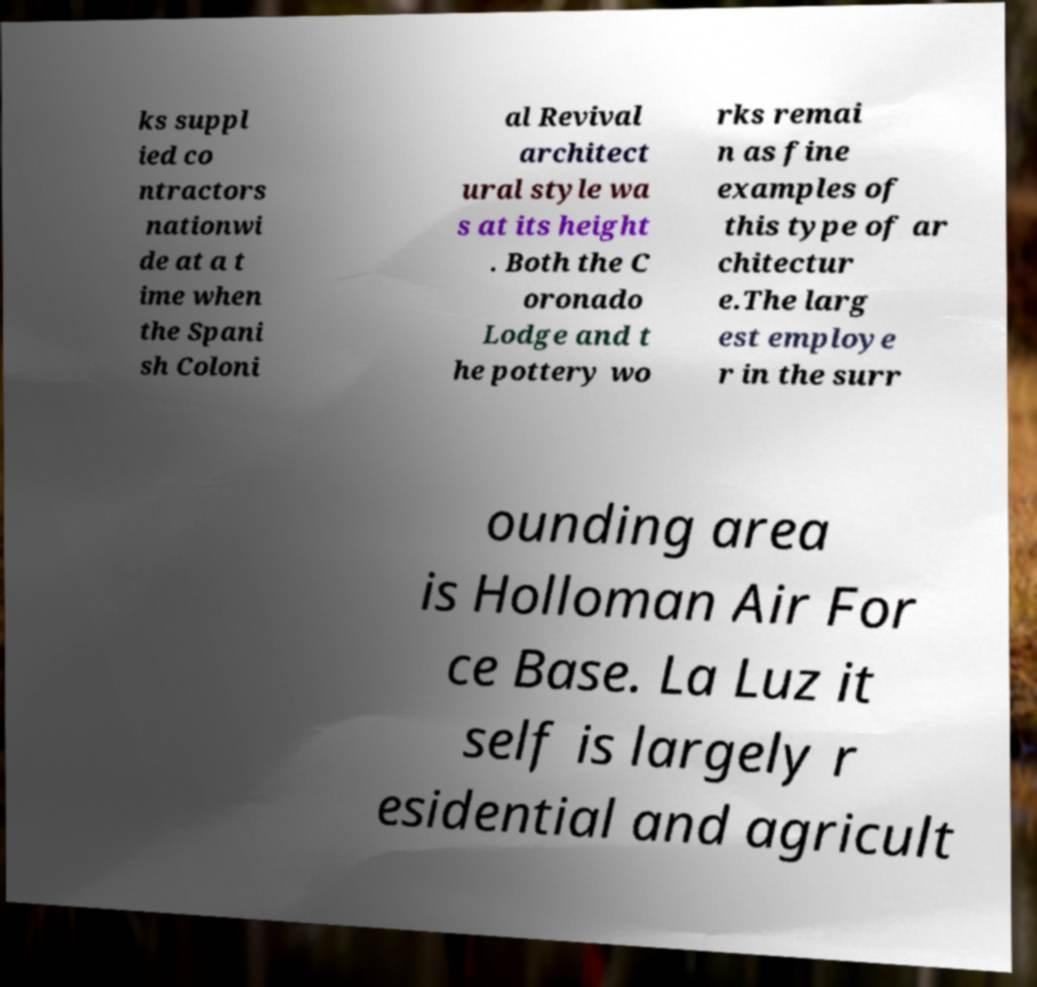For documentation purposes, I need the text within this image transcribed. Could you provide that? ks suppl ied co ntractors nationwi de at a t ime when the Spani sh Coloni al Revival architect ural style wa s at its height . Both the C oronado Lodge and t he pottery wo rks remai n as fine examples of this type of ar chitectur e.The larg est employe r in the surr ounding area is Holloman Air For ce Base. La Luz it self is largely r esidential and agricult 